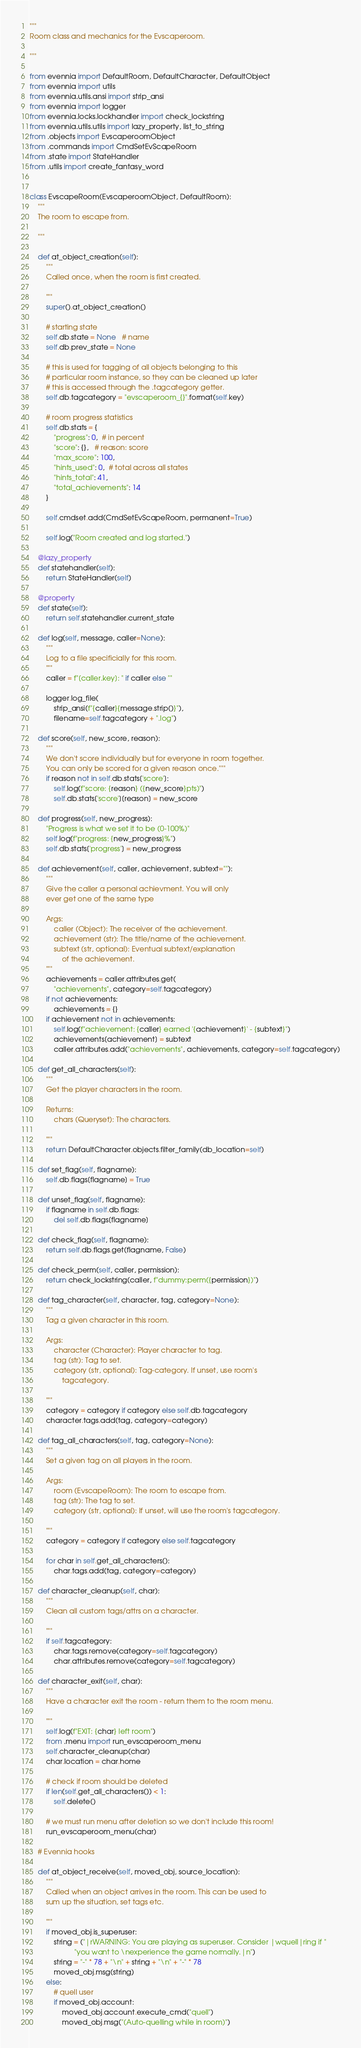Convert code to text. <code><loc_0><loc_0><loc_500><loc_500><_Python_>"""
Room class and mechanics for the Evscaperoom.

"""

from evennia import DefaultRoom, DefaultCharacter, DefaultObject
from evennia import utils
from evennia.utils.ansi import strip_ansi
from evennia import logger
from evennia.locks.lockhandler import check_lockstring
from evennia.utils.utils import lazy_property, list_to_string
from .objects import EvscaperoomObject
from .commands import CmdSetEvScapeRoom
from .state import StateHandler
from .utils import create_fantasy_word


class EvscapeRoom(EvscaperoomObject, DefaultRoom):
    """
    The room to escape from.

    """

    def at_object_creation(self):
        """
        Called once, when the room is first created.

        """
        super().at_object_creation()

        # starting state
        self.db.state = None   # name
        self.db.prev_state = None

        # this is used for tagging of all objects belonging to this
        # particular room instance, so they can be cleaned up later
        # this is accessed through the .tagcategory getter.
        self.db.tagcategory = "evscaperoom_{}".format(self.key)

        # room progress statistics
        self.db.stats = {
            "progress": 0,  # in percent
            "score": {},   # reason: score
            "max_score": 100,
            "hints_used": 0,  # total across all states
            "hints_total": 41,
            "total_achievements": 14
        }

        self.cmdset.add(CmdSetEvScapeRoom, permanent=True)

        self.log("Room created and log started.")

    @lazy_property
    def statehandler(self):
        return StateHandler(self)

    @property
    def state(self):
        return self.statehandler.current_state

    def log(self, message, caller=None):
        """
        Log to a file specificially for this room.
        """
        caller = f"[caller.key]: " if caller else ""

        logger.log_file(
            strip_ansi(f"{caller}{message.strip()}"),
            filename=self.tagcategory + ".log")

    def score(self, new_score, reason):
        """
        We don't score individually but for everyone in room together.
        You can only be scored for a given reason once."""
        if reason not in self.db.stats['score']:
            self.log(f"score: {reason} ({new_score}pts)")
            self.db.stats['score'][reason] = new_score

    def progress(self, new_progress):
        "Progress is what we set it to be (0-100%)"
        self.log(f"progress: {new_progress}%")
        self.db.stats['progress'] = new_progress

    def achievement(self, caller, achievement, subtext=""):
        """
        Give the caller a personal achievment. You will only
        ever get one of the same type

        Args:
            caller (Object): The receiver of the achievement.
            achievement (str): The title/name of the achievement.
            subtext (str, optional): Eventual subtext/explanation
                of the achievement.
        """
        achievements = caller.attributes.get(
            "achievements", category=self.tagcategory)
        if not achievements:
            achievements = {}
        if achievement not in achievements:
            self.log(f"achievement: {caller} earned '{achievement}' - {subtext}")
            achievements[achievement] = subtext
            caller.attributes.add("achievements", achievements, category=self.tagcategory)

    def get_all_characters(self):
        """
        Get the player characters in the room.

        Returns:
            chars (Queryset): The characters.

        """
        return DefaultCharacter.objects.filter_family(db_location=self)

    def set_flag(self, flagname):
        self.db.flags[flagname] = True

    def unset_flag(self, flagname):
        if flagname in self.db.flags:
            del self.db.flags[flagname]

    def check_flag(self, flagname):
        return self.db.flags.get(flagname, False)

    def check_perm(self, caller, permission):
        return check_lockstring(caller, f"dummy:perm({permission})")

    def tag_character(self, character, tag, category=None):
        """
        Tag a given character in this room.

        Args:
            character (Character): Player character to tag.
            tag (str): Tag to set.
            category (str, optional): Tag-category. If unset, use room's
                tagcategory.

        """
        category = category if category else self.db.tagcategory
        character.tags.add(tag, category=category)

    def tag_all_characters(self, tag, category=None):
        """
        Set a given tag on all players in the room.

        Args:
            room (EvscapeRoom): The room to escape from.
            tag (str): The tag to set.
            category (str, optional): If unset, will use the room's tagcategory.

        """
        category = category if category else self.tagcategory

        for char in self.get_all_characters():
            char.tags.add(tag, category=category)

    def character_cleanup(self, char):
        """
        Clean all custom tags/attrs on a character.

        """
        if self.tagcategory:
            char.tags.remove(category=self.tagcategory)
            char.attributes.remove(category=self.tagcategory)

    def character_exit(self, char):
        """
        Have a character exit the room - return them to the room menu.

        """
        self.log(f"EXIT: {char} left room")
        from .menu import run_evscaperoom_menu
        self.character_cleanup(char)
        char.location = char.home

        # check if room should be deleted
        if len(self.get_all_characters()) < 1:
            self.delete()

        # we must run menu after deletion so we don't include this room!
        run_evscaperoom_menu(char)

    # Evennia hooks

    def at_object_receive(self, moved_obj, source_location):
        """
        Called when an object arrives in the room. This can be used to
        sum up the situation, set tags etc.

        """
        if moved_obj.is_superuser:
            string = ("|rWARNING: You are playing as superuser. Consider |wquell|ring if "
                      "you want to \nexperience the game normally.|n")
            string = "-" * 78 + "\n" + string + "\n" + "-" * 78
            moved_obj.msg(string)
        else:
            # quell user
            if moved_obj.account:
                moved_obj.account.execute_cmd("quell")
                moved_obj.msg("(Auto-quelling while in room)")
</code> 